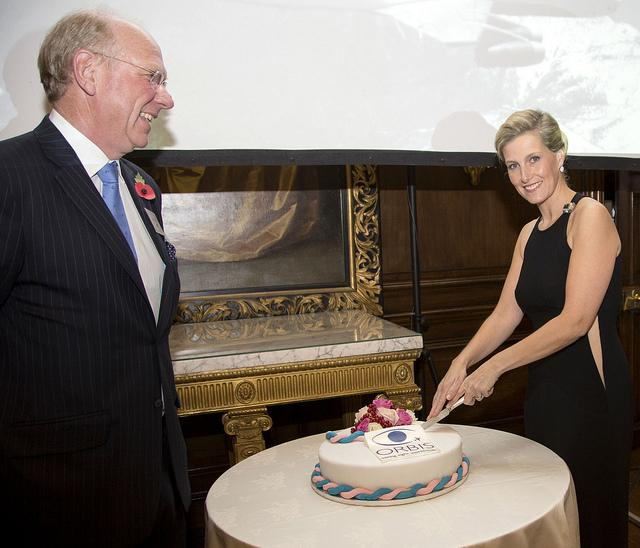What is the name of the red flower on the man's lapel? poppy 